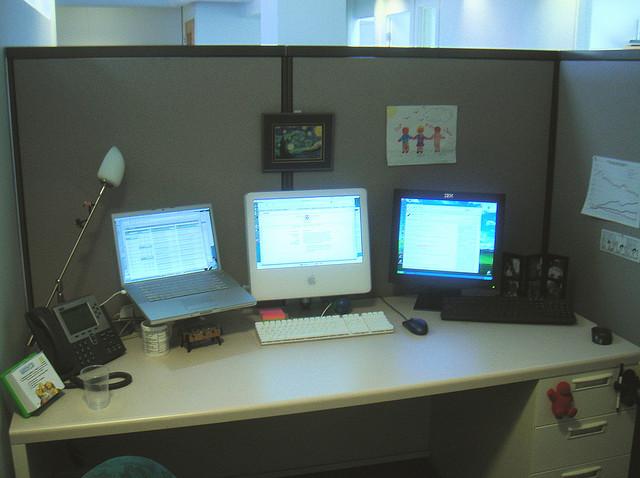Is the desk messy?
Be succinct. No. Has this cubicle been personalized?
Concise answer only. Yes. Why is the laptop raised from the keyboard?
Keep it brief. Better performance. Are these computers on?
Be succinct. Yes. Are the computers in a cubicle?
Quick response, please. Yes. How many comps are there?
Answer briefly. 3. How many pieces of paper are hanging in the cubicle?
Be succinct. 2. How many display screens are on?
Answer briefly. 3. 